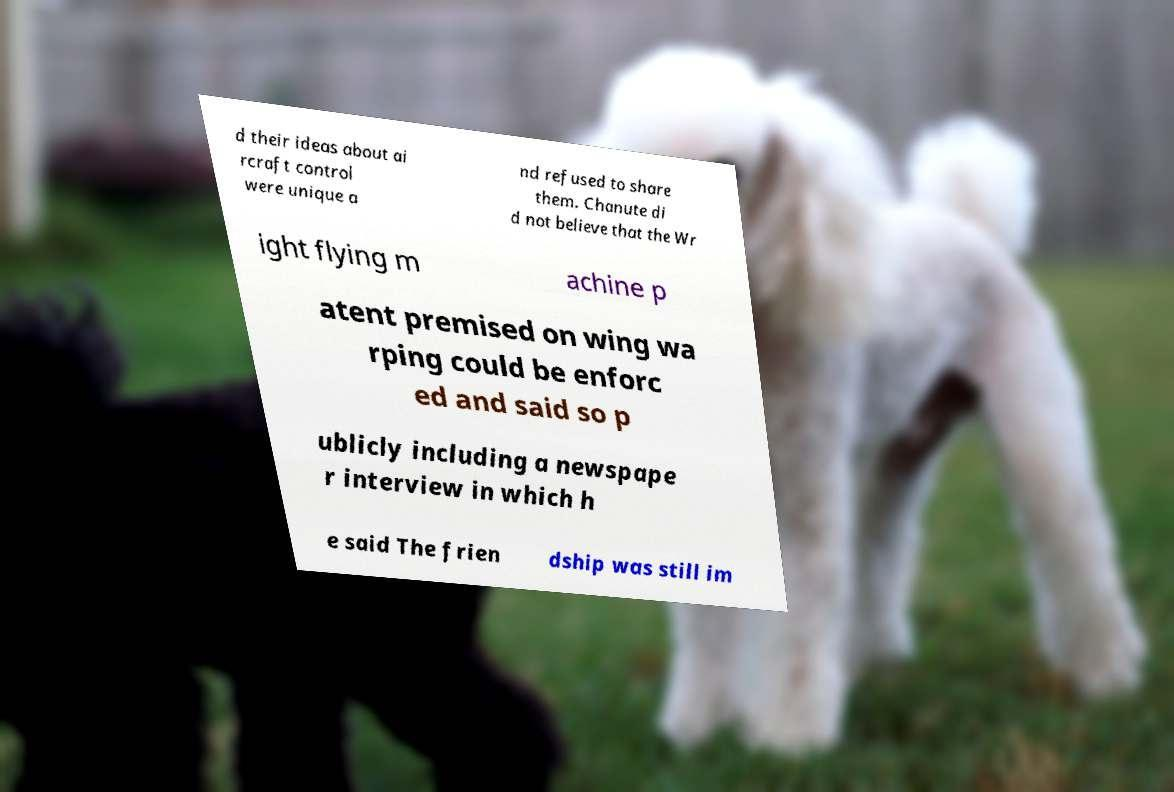What messages or text are displayed in this image? I need them in a readable, typed format. d their ideas about ai rcraft control were unique a nd refused to share them. Chanute di d not believe that the Wr ight flying m achine p atent premised on wing wa rping could be enforc ed and said so p ublicly including a newspape r interview in which h e said The frien dship was still im 